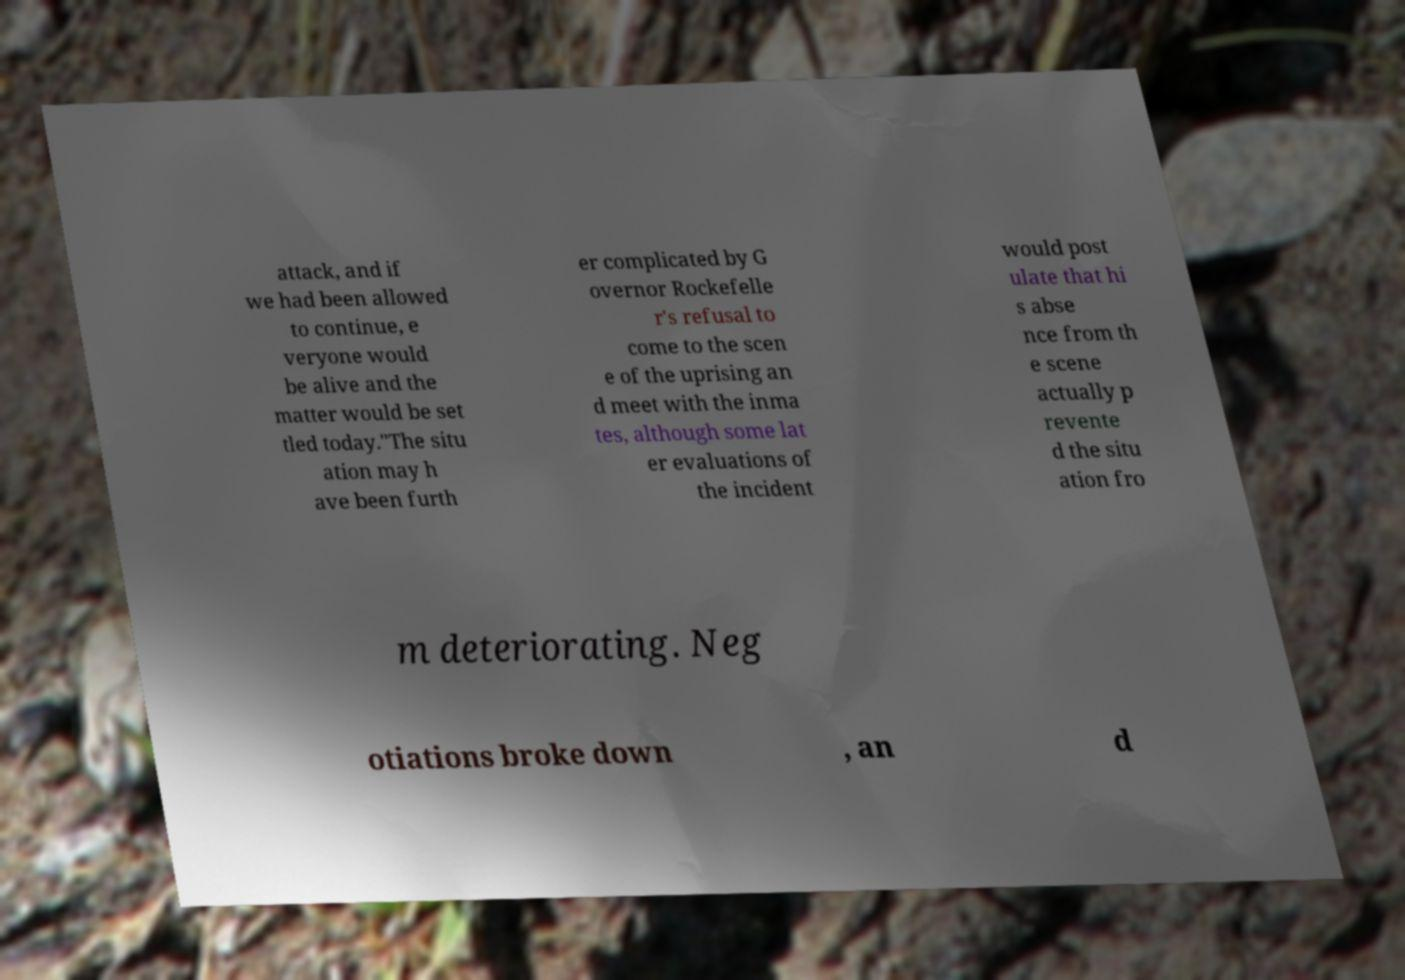What messages or text are displayed in this image? I need them in a readable, typed format. attack, and if we had been allowed to continue, e veryone would be alive and the matter would be set tled today."The situ ation may h ave been furth er complicated by G overnor Rockefelle r's refusal to come to the scen e of the uprising an d meet with the inma tes, although some lat er evaluations of the incident would post ulate that hi s abse nce from th e scene actually p revente d the situ ation fro m deteriorating. Neg otiations broke down , an d 